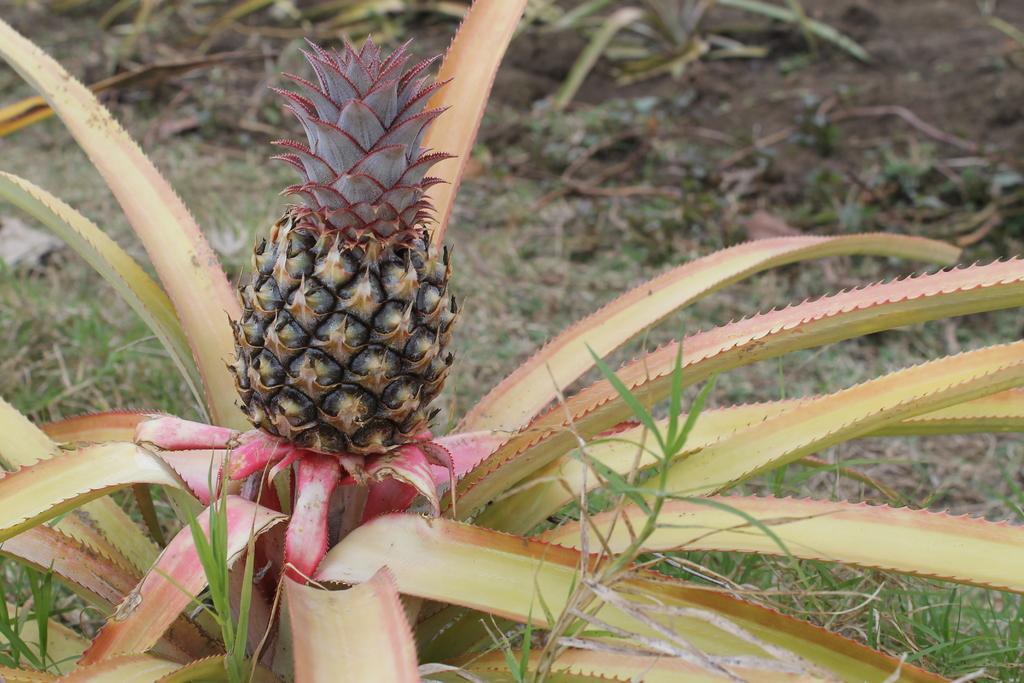In one or two sentences, can you explain what this image depicts? Here we can see a pineapple plant with pineapple. Background it is blur. We can see grass. 